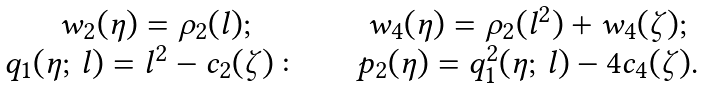Convert formula to latex. <formula><loc_0><loc_0><loc_500><loc_500>\begin{matrix} w _ { 2 } ( \eta ) = \rho _ { 2 } ( l ) ; \quad & w _ { 4 } ( \eta ) = \rho _ { 2 } ( l ^ { 2 } ) + w _ { 4 } ( \zeta ) ; \\ q _ { 1 } ( \eta ; \, l ) = l ^ { 2 } - c _ { 2 } ( \zeta ) \colon \quad & p _ { 2 } ( \eta ) = q _ { 1 } ^ { 2 } ( \eta ; \, l ) - 4 c _ { 4 } ( \zeta ) . \end{matrix}</formula> 